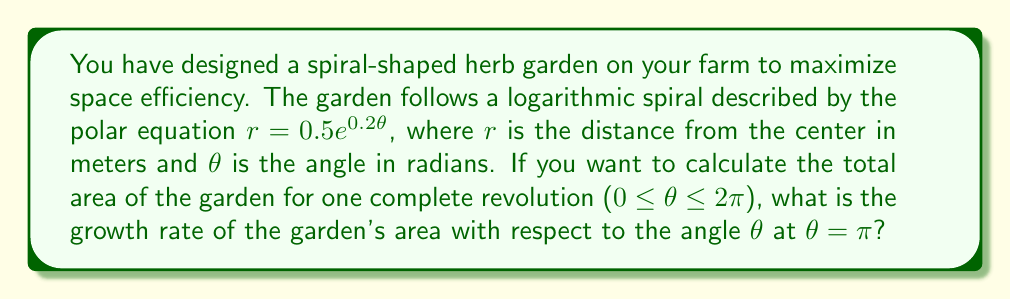Help me with this question. To solve this problem, we'll follow these steps:

1) The area of a polar region is given by the formula:

   $$A = \frac{1}{2} \int_a^b r^2 d\theta$$

2) In our case, $r = 0.5e^{0.2\theta}$, so $r^2 = 0.25e^{0.4\theta}$

3) The area function is:

   $$A(\theta) = \frac{1}{2} \int_0^\theta 0.25e^{0.4\theta} d\theta$$

4) To find the growth rate, we need to differentiate this with respect to θ:

   $$\frac{dA}{d\theta} = \frac{1}{2} \cdot 0.25e^{0.4\theta} = 0.125e^{0.4\theta}$$

5) This represents the instantaneous growth rate of the area at any angle θ.

6) To find the growth rate at θ = π, we substitute this value:

   $$\left.\frac{dA}{d\theta}\right|_{\theta=\pi} = 0.125e^{0.4\pi}$$

7) Calculate the value:

   $$0.125e^{0.4\pi} \approx 0.6554$$ m²/radian

This means that at θ = π, the area of the garden is increasing at a rate of approximately 0.6554 square meters per radian.
Answer: The growth rate of the garden's area with respect to θ at θ = π is approximately 0.6554 m²/radian. 